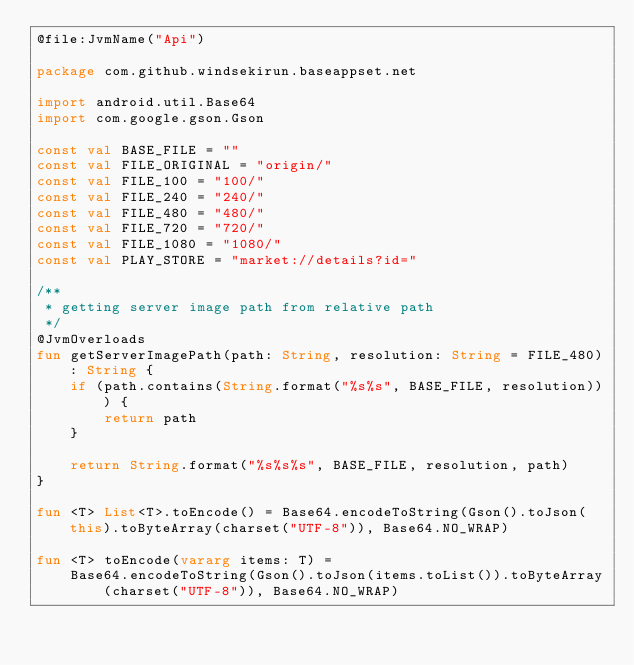<code> <loc_0><loc_0><loc_500><loc_500><_Kotlin_>@file:JvmName("Api")

package com.github.windsekirun.baseappset.net

import android.util.Base64
import com.google.gson.Gson

const val BASE_FILE = ""
const val FILE_ORIGINAL = "origin/"
const val FILE_100 = "100/"
const val FILE_240 = "240/"
const val FILE_480 = "480/"
const val FILE_720 = "720/"
const val FILE_1080 = "1080/"
const val PLAY_STORE = "market://details?id="

/**
 * getting server image path from relative path
 */
@JvmOverloads
fun getServerImagePath(path: String, resolution: String = FILE_480): String {
    if (path.contains(String.format("%s%s", BASE_FILE, resolution))) {
        return path
    }

    return String.format("%s%s%s", BASE_FILE, resolution, path)
}

fun <T> List<T>.toEncode() = Base64.encodeToString(Gson().toJson(this).toByteArray(charset("UTF-8")), Base64.NO_WRAP)

fun <T> toEncode(vararg items: T) =
    Base64.encodeToString(Gson().toJson(items.toList()).toByteArray(charset("UTF-8")), Base64.NO_WRAP)</code> 